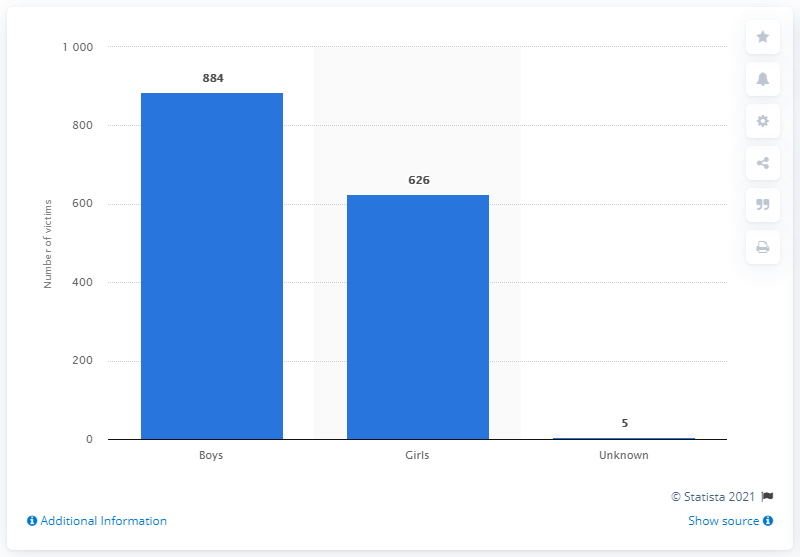Give some essential details in this illustration. In 2019, it is estimated that 626 girls in the United States lost their lives due to abuse. 